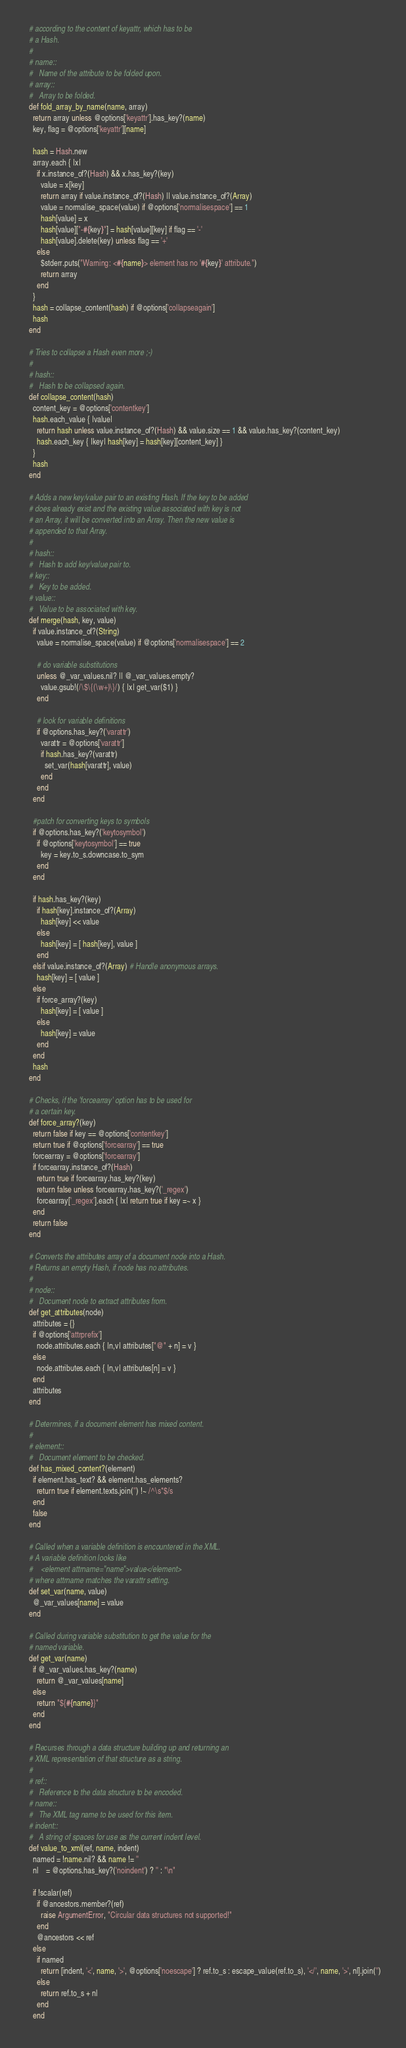Convert code to text. <code><loc_0><loc_0><loc_500><loc_500><_Ruby_>  # according to the content of keyattr, which has to be
  # a Hash.
  #
  # name::
  #   Name of the attribute to be folded upon.
  # array::
  #   Array to be folded.
  def fold_array_by_name(name, array)
    return array unless @options['keyattr'].has_key?(name)
    key, flag = @options['keyattr'][name]

    hash = Hash.new
    array.each { |x|
      if x.instance_of?(Hash) && x.has_key?(key)
        value = x[key]
        return array if value.instance_of?(Hash) || value.instance_of?(Array)
        value = normalise_space(value) if @options['normalisespace'] == 1
        hash[value] = x
        hash[value]["-#{key}"] = hash[value][key] if flag == '-'
        hash[value].delete(key) unless flag == '+'
      else
        $stderr.puts("Warning: <#{name}> element has no '#{key}' attribute.")
        return array
      end
    }
    hash = collapse_content(hash) if @options['collapseagain']
    hash
  end

  # Tries to collapse a Hash even more ;-)
  #
  # hash::
  #   Hash to be collapsed again.
  def collapse_content(hash)
    content_key = @options['contentkey']
    hash.each_value { |value|
      return hash unless value.instance_of?(Hash) && value.size == 1 && value.has_key?(content_key)
      hash.each_key { |key| hash[key] = hash[key][content_key] }
    }
    hash
  end
  
  # Adds a new key/value pair to an existing Hash. If the key to be added
  # does already exist and the existing value associated with key is not
  # an Array, it will be converted into an Array. Then the new value is
  # appended to that Array.
  #
  # hash::
  #   Hash to add key/value pair to.
  # key::
  #   Key to be added.
  # value::
  #   Value to be associated with key.
  def merge(hash, key, value)
    if value.instance_of?(String)
      value = normalise_space(value) if @options['normalisespace'] == 2

      # do variable substitutions
      unless @_var_values.nil? || @_var_values.empty?
        value.gsub!(/\$\{(\w+)\}/) { |x| get_var($1) }
      end
      
      # look for variable definitions
      if @options.has_key?('varattr')
        varattr = @options['varattr']
        if hash.has_key?(varattr)
          set_var(hash[varattr], value)
        end
      end
    end
    
    #patch for converting keys to symbols
    if @options.has_key?('keytosymbol')
      if @options['keytosymbol'] == true
        key = key.to_s.downcase.to_sym
      end
    end
    
    if hash.has_key?(key)
      if hash[key].instance_of?(Array)
        hash[key] << value
      else
        hash[key] = [ hash[key], value ]
      end
    elsif value.instance_of?(Array) # Handle anonymous arrays.
      hash[key] = [ value ]
    else
      if force_array?(key)
        hash[key] = [ value ]
      else
        hash[key] = value
      end
    end
    hash
  end
  
  # Checks, if the 'forcearray' option has to be used for
  # a certain key.
  def force_array?(key)
    return false if key == @options['contentkey']
    return true if @options['forcearray'] == true
    forcearray = @options['forcearray']
    if forcearray.instance_of?(Hash)
      return true if forcearray.has_key?(key) 
      return false unless forcearray.has_key?('_regex')
      forcearray['_regex'].each { |x| return true if key =~ x }
    end
    return false
  end
  
  # Converts the attributes array of a document node into a Hash.
  # Returns an empty Hash, if node has no attributes.
  #
  # node::
  #   Document node to extract attributes from.
  def get_attributes(node)
    attributes = {}
    if @options['attrprefix']
      node.attributes.each { |n,v| attributes["@" + n] = v }
    else
      node.attributes.each { |n,v| attributes[n] = v }
    end
    attributes
  end
  
  # Determines, if a document element has mixed content.
  #
  # element::
  #   Document element to be checked.
  def has_mixed_content?(element)
    if element.has_text? && element.has_elements?
      return true if element.texts.join('') !~ /^\s*$/s
    end
    false
  end
  
  # Called when a variable definition is encountered in the XML.
  # A variable definition looks like
  #    <element attrname="name">value</element>
  # where attrname matches the varattr setting.
  def set_var(name, value)
    @_var_values[name] = value
  end

  # Called during variable substitution to get the value for the
  # named variable.
  def get_var(name)
    if @_var_values.has_key?(name)
      return @_var_values[name]
    else
      return "${#{name}}"
    end
  end
  
  # Recurses through a data structure building up and returning an
  # XML representation of that structure as a string.
  #
  # ref::
  #   Reference to the data structure to be encoded.
  # name::
  #   The XML tag name to be used for this item.
  # indent::
  #   A string of spaces for use as the current indent level.
  def value_to_xml(ref, name, indent)
    named = !name.nil? && name != ''
    nl    = @options.has_key?('noindent') ? '' : "\n"

    if !scalar(ref)
      if @ancestors.member?(ref)
        raise ArgumentError, "Circular data structures not supported!"
      end
      @ancestors << ref
    else
      if named
        return [indent, '<', name, '>', @options['noescape'] ? ref.to_s : escape_value(ref.to_s), '</', name, '>', nl].join('')
      else
        return ref.to_s + nl
      end
    end
</code> 